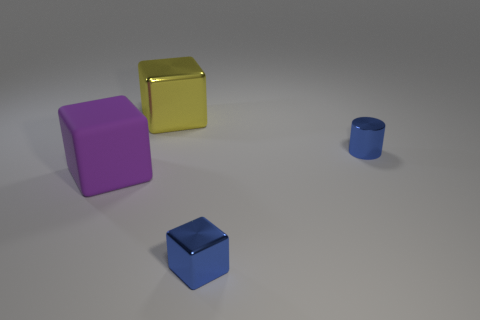There is a small object that is the same color as the metal cylinder; what material is it?
Provide a succinct answer. Metal. What number of big rubber blocks are to the right of the yellow metal block?
Make the answer very short. 0. There is a tiny shiny thing that is the same shape as the big purple rubber thing; what color is it?
Offer a terse response. Blue. How many metallic objects are either big purple blocks or large objects?
Offer a very short reply. 1. Are there any blue shiny cylinders on the left side of the blue shiny thing that is to the right of the tiny blue shiny thing in front of the metal cylinder?
Provide a short and direct response. No. The big metallic block has what color?
Your answer should be very brief. Yellow. There is a large object that is behind the big purple matte thing; is it the same shape as the big matte object?
Offer a terse response. Yes. How many objects are either blue shiny cubes or cubes on the left side of the big yellow metal thing?
Your response must be concise. 2. Is the block behind the large matte object made of the same material as the large purple block?
Make the answer very short. No. There is a big block in front of the metallic cylinder right of the large yellow shiny cube; what is it made of?
Your response must be concise. Rubber. 